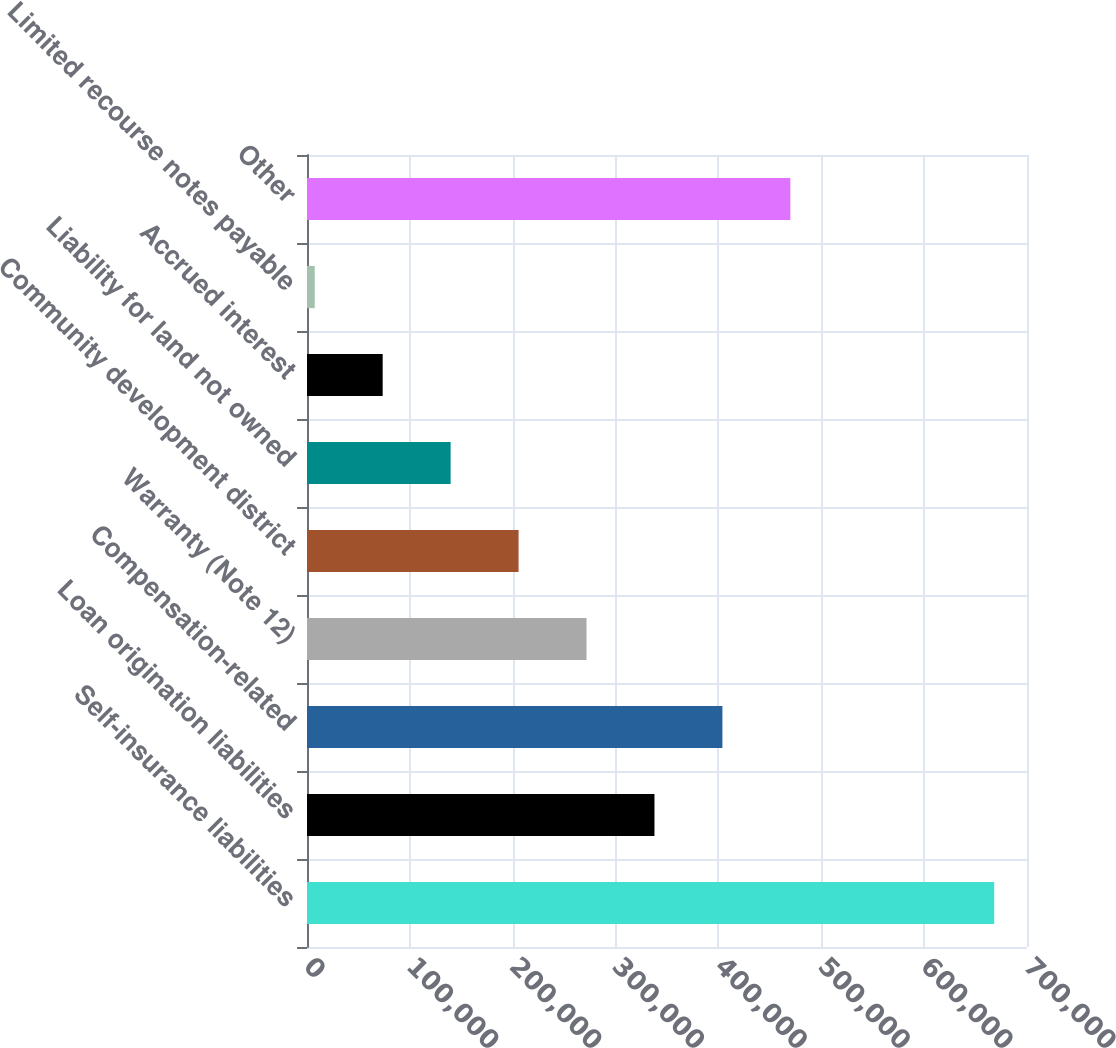Convert chart. <chart><loc_0><loc_0><loc_500><loc_500><bar_chart><fcel>Self-insurance liabilities<fcel>Loan origination liabilities<fcel>Compensation-related<fcel>Warranty (Note 12)<fcel>Community development district<fcel>Liability for land not owned<fcel>Accrued interest<fcel>Limited recourse notes payable<fcel>Other<nl><fcel>668100<fcel>337810<fcel>403868<fcel>271753<fcel>205695<fcel>139637<fcel>73578.9<fcel>7521<fcel>469926<nl></chart> 